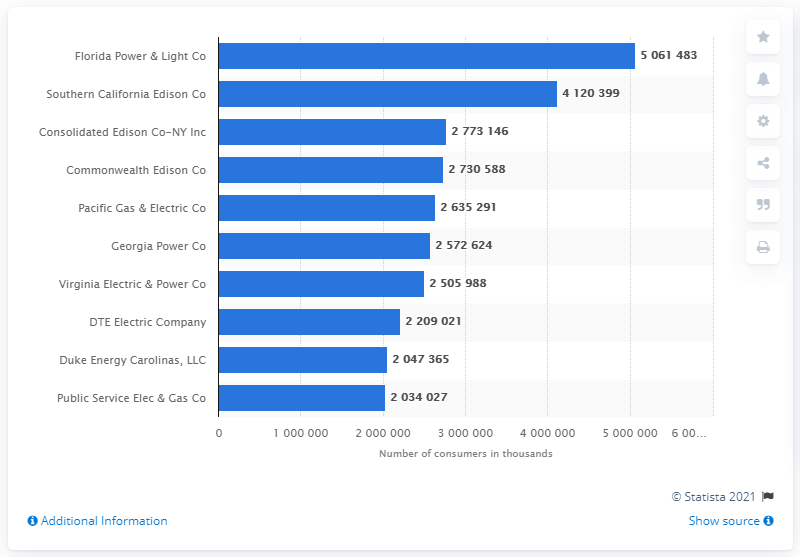List a handful of essential elements in this visual. In the year 2019, Florida Power and Light served a total of 506,1483 customers. 